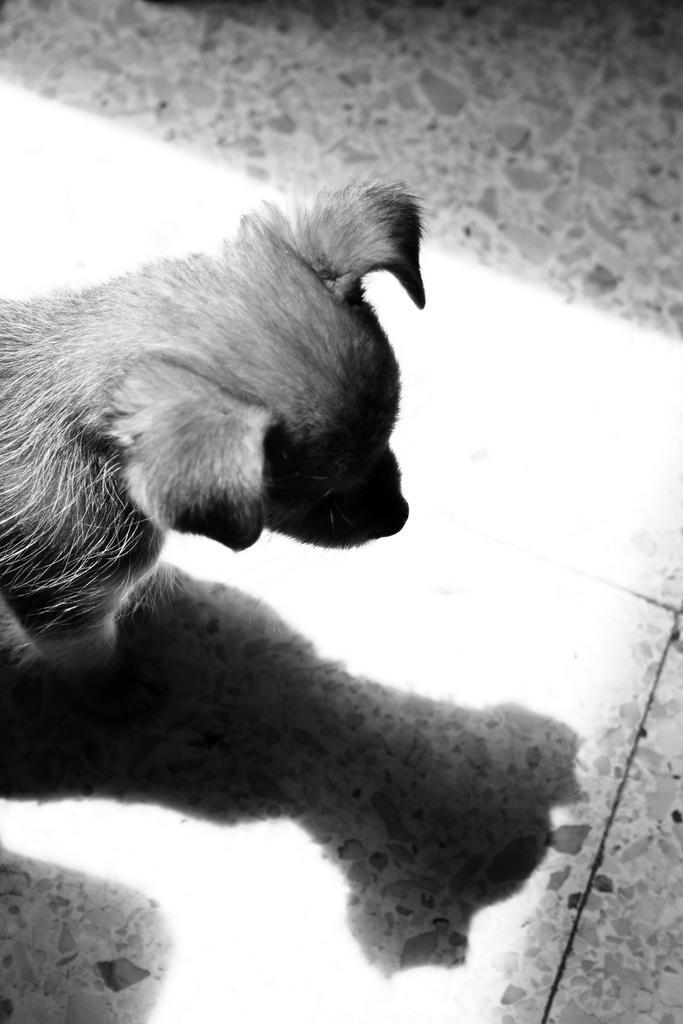What type of animal is in the image? There is a dog in the image. Where is the dog located in the image? The dog is on the floor. What is the dog doing in the image? The dog is looking at its image in a title. What type of glass is the dog drinking from in the image? There is no glass present in the image, and the dog is not drinking anything. 